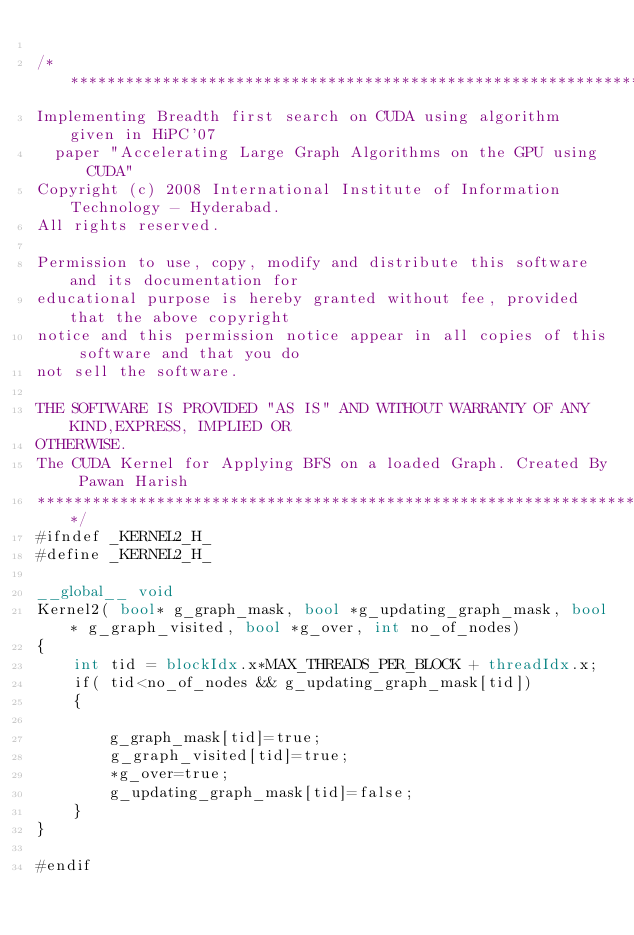Convert code to text. <code><loc_0><loc_0><loc_500><loc_500><_Cuda_>
/*********************************************************************************
Implementing Breadth first search on CUDA using algorithm given in HiPC'07
  paper "Accelerating Large Graph Algorithms on the GPU using CUDA"
Copyright (c) 2008 International Institute of Information Technology - Hyderabad. 
All rights reserved.
  
Permission to use, copy, modify and distribute this software and its documentation for 
educational purpose is hereby granted without fee, provided that the above copyright 
notice and this permission notice appear in all copies of this software and that you do 
not sell the software.
  
THE SOFTWARE IS PROVIDED "AS IS" AND WITHOUT WARRANTY OF ANY KIND,EXPRESS, IMPLIED OR 
OTHERWISE.
The CUDA Kernel for Applying BFS on a loaded Graph. Created By Pawan Harish
**********************************************************************************/
#ifndef _KERNEL2_H_
#define _KERNEL2_H_

__global__ void
Kernel2( bool* g_graph_mask, bool *g_updating_graph_mask, bool* g_graph_visited, bool *g_over, int no_of_nodes)
{
	int tid = blockIdx.x*MAX_THREADS_PER_BLOCK + threadIdx.x;
	if( tid<no_of_nodes && g_updating_graph_mask[tid])
	{

		g_graph_mask[tid]=true;
		g_graph_visited[tid]=true;
		*g_over=true;
		g_updating_graph_mask[tid]=false;
	}
}

#endif</code> 